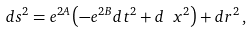<formula> <loc_0><loc_0><loc_500><loc_500>d s ^ { 2 } = e ^ { 2 A } \left ( - e ^ { 2 B } d t ^ { 2 } + d \ x ^ { 2 } \right ) + d r ^ { 2 } \, ,</formula> 